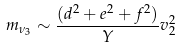Convert formula to latex. <formula><loc_0><loc_0><loc_500><loc_500>m _ { \nu _ { 3 } } \sim \frac { ( d ^ { 2 } + e ^ { 2 } + f ^ { 2 } ) } { Y } v _ { 2 } ^ { 2 }</formula> 